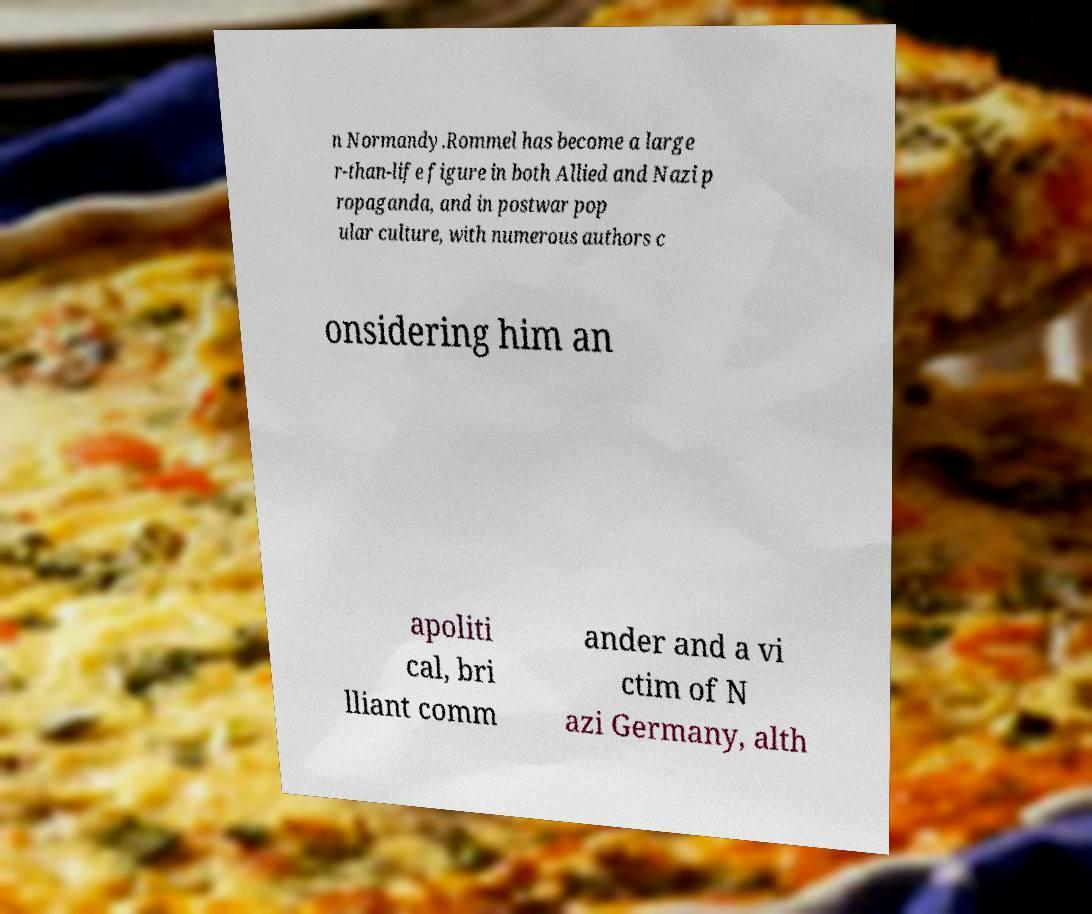For documentation purposes, I need the text within this image transcribed. Could you provide that? n Normandy.Rommel has become a large r-than-life figure in both Allied and Nazi p ropaganda, and in postwar pop ular culture, with numerous authors c onsidering him an apoliti cal, bri lliant comm ander and a vi ctim of N azi Germany, alth 